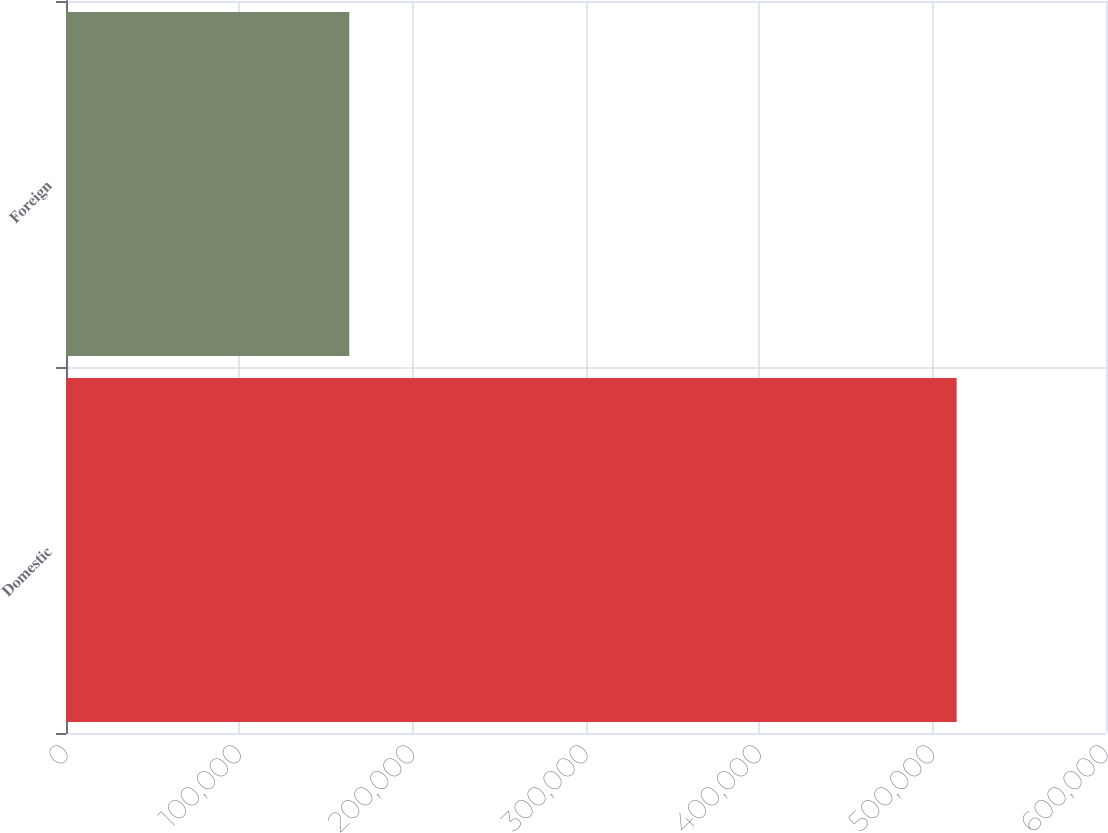Convert chart. <chart><loc_0><loc_0><loc_500><loc_500><bar_chart><fcel>Domestic<fcel>Foreign<nl><fcel>513844<fcel>163437<nl></chart> 